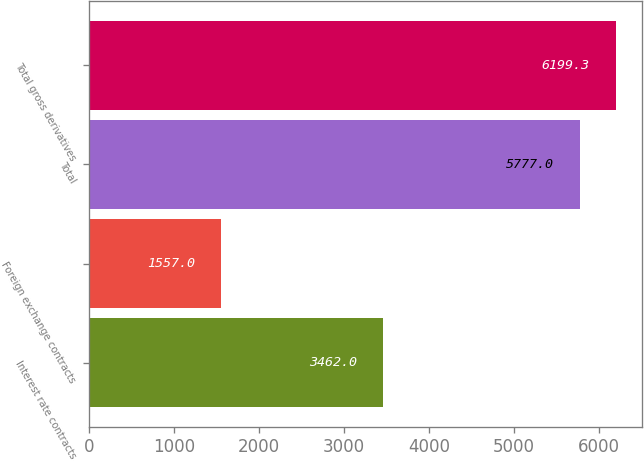<chart> <loc_0><loc_0><loc_500><loc_500><bar_chart><fcel>Interest rate contracts<fcel>Foreign exchange contracts<fcel>Total<fcel>Total gross derivatives<nl><fcel>3462<fcel>1557<fcel>5777<fcel>6199.3<nl></chart> 